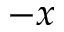<formula> <loc_0><loc_0><loc_500><loc_500>- x</formula> 